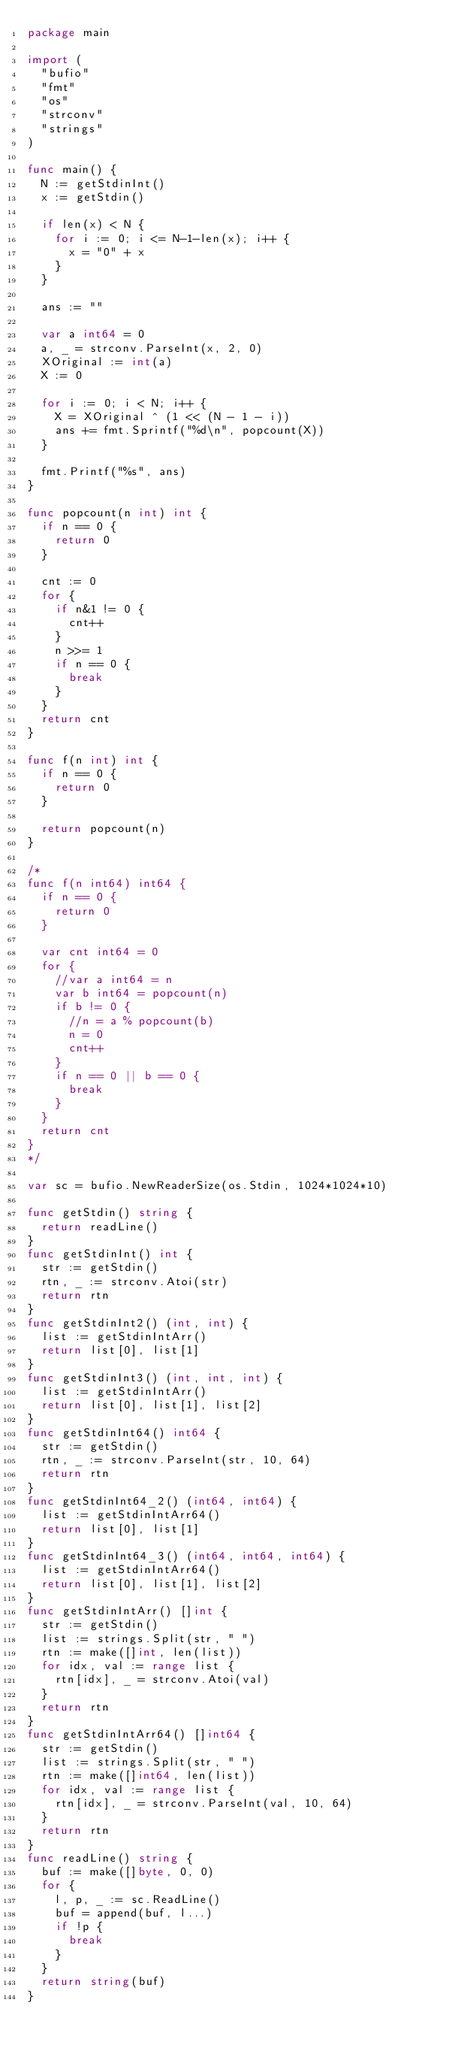Convert code to text. <code><loc_0><loc_0><loc_500><loc_500><_Go_>package main

import (
	"bufio"
	"fmt"
	"os"
	"strconv"
	"strings"
)

func main() {
	N := getStdinInt()
	x := getStdin()

	if len(x) < N {
		for i := 0; i <= N-1-len(x); i++ {
			x = "0" + x
		}
	}

	ans := ""

	var a int64 = 0
	a, _ = strconv.ParseInt(x, 2, 0)
	XOriginal := int(a)
	X := 0

	for i := 0; i < N; i++ {
		X = XOriginal ^ (1 << (N - 1 - i))
		ans += fmt.Sprintf("%d\n", popcount(X))
	}

	fmt.Printf("%s", ans)
}

func popcount(n int) int {
	if n == 0 {
		return 0
	}

	cnt := 0
	for {
		if n&1 != 0 {
			cnt++
		}
		n >>= 1
		if n == 0 {
			break
		}
	}
	return cnt
}

func f(n int) int {
	if n == 0 {
		return 0
	}

	return popcount(n)
}

/*
func f(n int64) int64 {
	if n == 0 {
		return 0
	}

	var cnt int64 = 0
	for {
		//var a int64 = n
		var b int64 = popcount(n)
		if b != 0 {
			//n = a % popcount(b)
			n = 0
			cnt++
		}
		if n == 0 || b == 0 {
			break
		}
	}
	return cnt
}
*/

var sc = bufio.NewReaderSize(os.Stdin, 1024*1024*10)

func getStdin() string {
	return readLine()
}
func getStdinInt() int {
	str := getStdin()
	rtn, _ := strconv.Atoi(str)
	return rtn
}
func getStdinInt2() (int, int) {
	list := getStdinIntArr()
	return list[0], list[1]
}
func getStdinInt3() (int, int, int) {
	list := getStdinIntArr()
	return list[0], list[1], list[2]
}
func getStdinInt64() int64 {
	str := getStdin()
	rtn, _ := strconv.ParseInt(str, 10, 64)
	return rtn
}
func getStdinInt64_2() (int64, int64) {
	list := getStdinIntArr64()
	return list[0], list[1]
}
func getStdinInt64_3() (int64, int64, int64) {
	list := getStdinIntArr64()
	return list[0], list[1], list[2]
}
func getStdinIntArr() []int {
	str := getStdin()
	list := strings.Split(str, " ")
	rtn := make([]int, len(list))
	for idx, val := range list {
		rtn[idx], _ = strconv.Atoi(val)
	}
	return rtn
}
func getStdinIntArr64() []int64 {
	str := getStdin()
	list := strings.Split(str, " ")
	rtn := make([]int64, len(list))
	for idx, val := range list {
		rtn[idx], _ = strconv.ParseInt(val, 10, 64)
	}
	return rtn
}
func readLine() string {
	buf := make([]byte, 0, 0)
	for {
		l, p, _ := sc.ReadLine()
		buf = append(buf, l...)
		if !p {
			break
		}
	}
	return string(buf)
}
</code> 